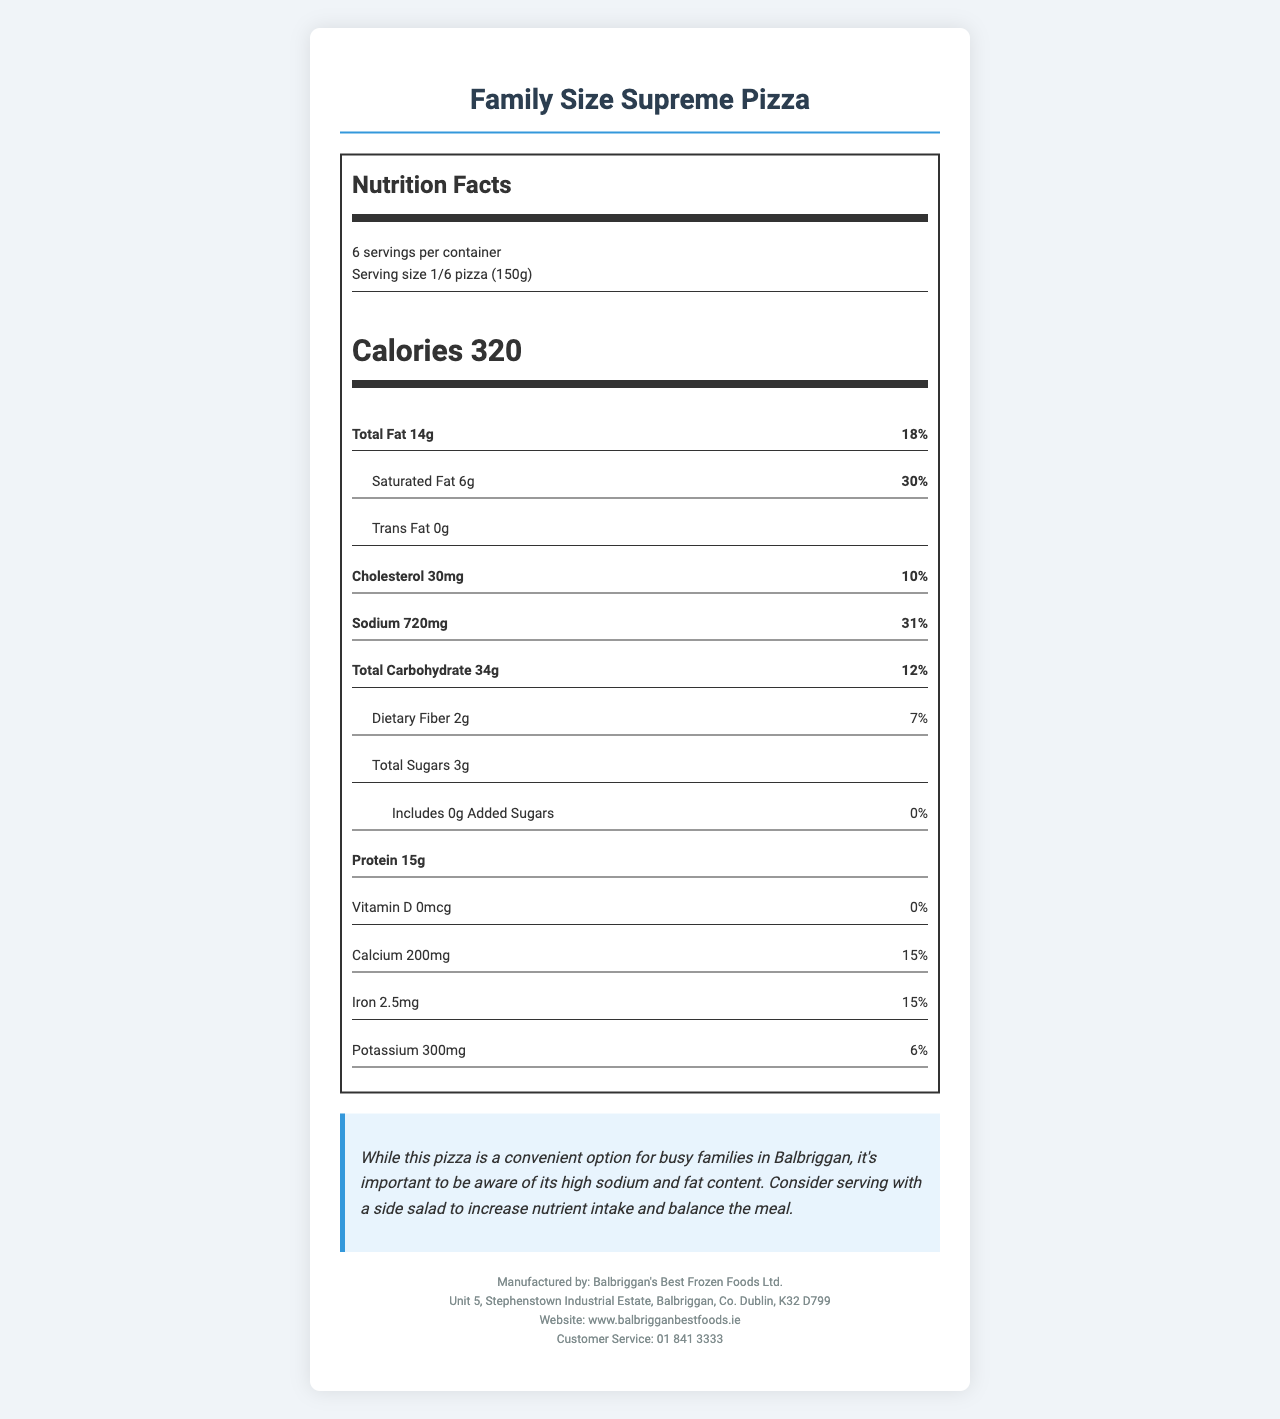what is the serving size? The serving size is clearly stated in the document under the "serving size" section as "1/6 pizza (150g)".
Answer: 1/6 pizza (150g) how many calories are in one serving? The number of calories per serving is provided in the "calorie-info" section of the document as 320.
Answer: 320 how much total fat is in one serving, in grams? The total fat per serving is listed in the "nutrient-info" section as 14 grams.
Answer: 14 grams what percent of the daily value is the saturated fat? The percent daily value for saturated fat is shown in the "nutrient-info" section as 30%.
Answer: 30% how much sodium is in one serving? The amount of sodium per serving is detailed in the "nutrient-info" section as 720 milligrams.
Answer: 720 milligrams which nutrient has the highest percent daily value? A. Cholesterol B. Sodium C. Saturated Fat D. Dietary Fiber Saturated fat has a percent daily value of 30%, which is the highest among the listed nutrients.
Answer: C. Saturated Fat what are the allergens mentioned in the document? A. Wheat, Milk, Soy B. Wheat, Milk, Nuts C. Soy, Milk, Eggs D. Wheat, Eggs, Fish The allergens listed in the document are "Wheat, Milk, Soy" as stated under the "allergens" section.
Answer: A. Wheat, Milk, Soy is there any added sugar in the pizza? The document states that the pizza has 0 grams of added sugars and the percent daily value is also 0%.
Answer: No is this pizza suitable for people trying to reduce their sodium intake? The document highlights that the pizza has a high sodium content, with one serving containing 720 milligrams, which is 31% of the daily value.
Answer: No describe the main idea of this document. The document is a comprehensive nutritional label for Family Size Supreme Pizza, offering insights into its nutritional values, guiding consumption, storage, and cooking, and advising on its suitability with a health claim and complementary meal suggestion.
Answer: The document provides detailed nutritional information about the Family Size Supreme Pizza, emphasizing its high fat and sodium content. It includes serving size, calories, total fat, saturated fat, cholesterol, sodium, and other nutrients. There's a health claim noting the high sodium and fat and a suggestion to balance the meal with a side salad. It also provides storage and cooking instructions, manufacturer details, and allergen information. how much protein does one serving provide? The document lists protein content in the "nutrient-info" section as 15 grams per serving.
Answer: 15 grams how many servings are there in one container? The number of servings per container is mentioned in the "serving-info" section as 6.
Answer: 6 how much dietary fiber does one serving contain? The dietary fiber amount is specified in the "nutrient-info" section as 2 grams per serving.
Answer: 2 grams is there any information about vitamin C content? The document does not provide any information regarding vitamin C content; it only mentions vitamin D.
Answer: Not enough information does the pizza contain trans fat? According to the document, the pizza has 0 grams of trans fat as indicated in the "nutrient-info" section.
Answer: No what is the health claim made in the document? The health claim in the document advises consumers to be aware of the high sodium and fat content and suggests adding a side salad to make the meal more balanced.
Answer: While this pizza is a convenient option for busy families in Balbriggan, it's important to be aware of its high sodium and fat content. Consider serving with a side salad to increase nutrient intake and balance the meal. 